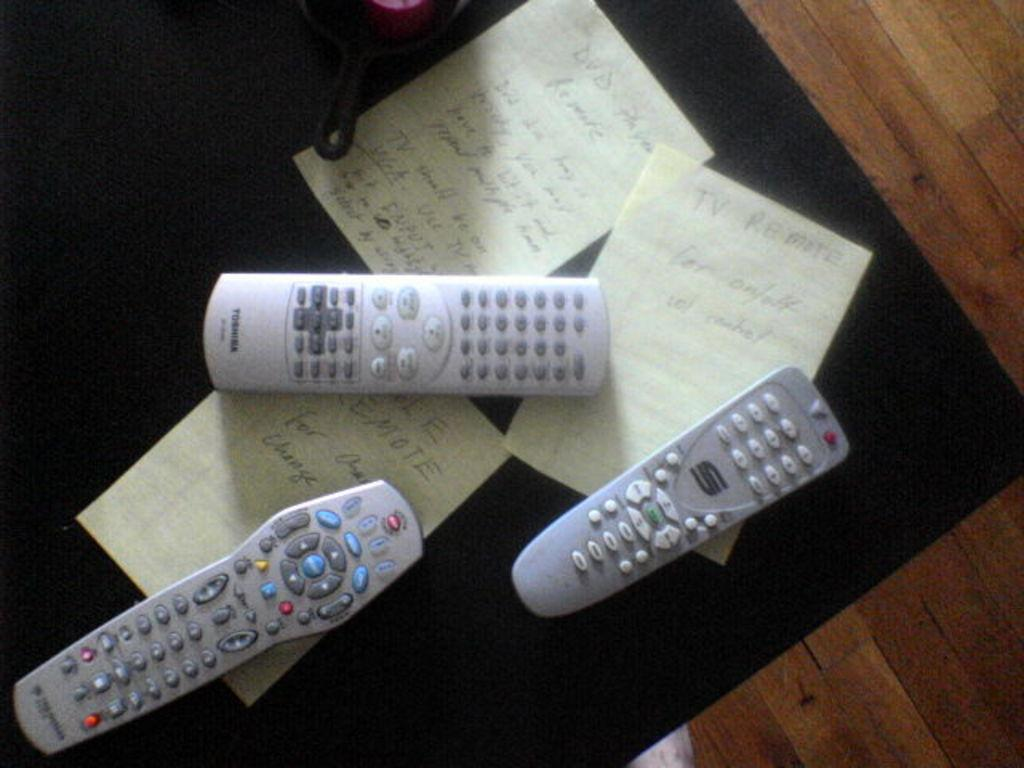<image>
Share a concise interpretation of the image provided. Three remote controllers including one from Toshiba on top of a table. 